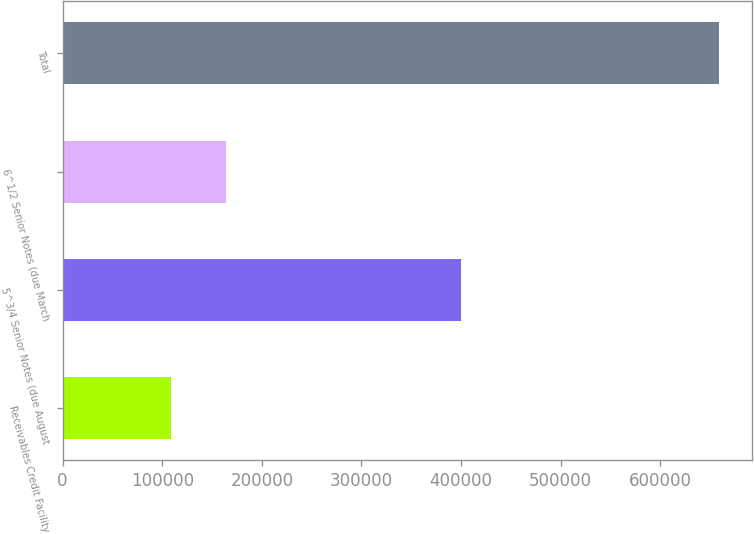Convert chart to OTSL. <chart><loc_0><loc_0><loc_500><loc_500><bar_chart><fcel>Receivables Credit Facility<fcel>5^3/4 Senior Notes (due August<fcel>6^1/2 Senior Notes (due March<fcel>Total<nl><fcel>109000<fcel>400000<fcel>164000<fcel>659000<nl></chart> 